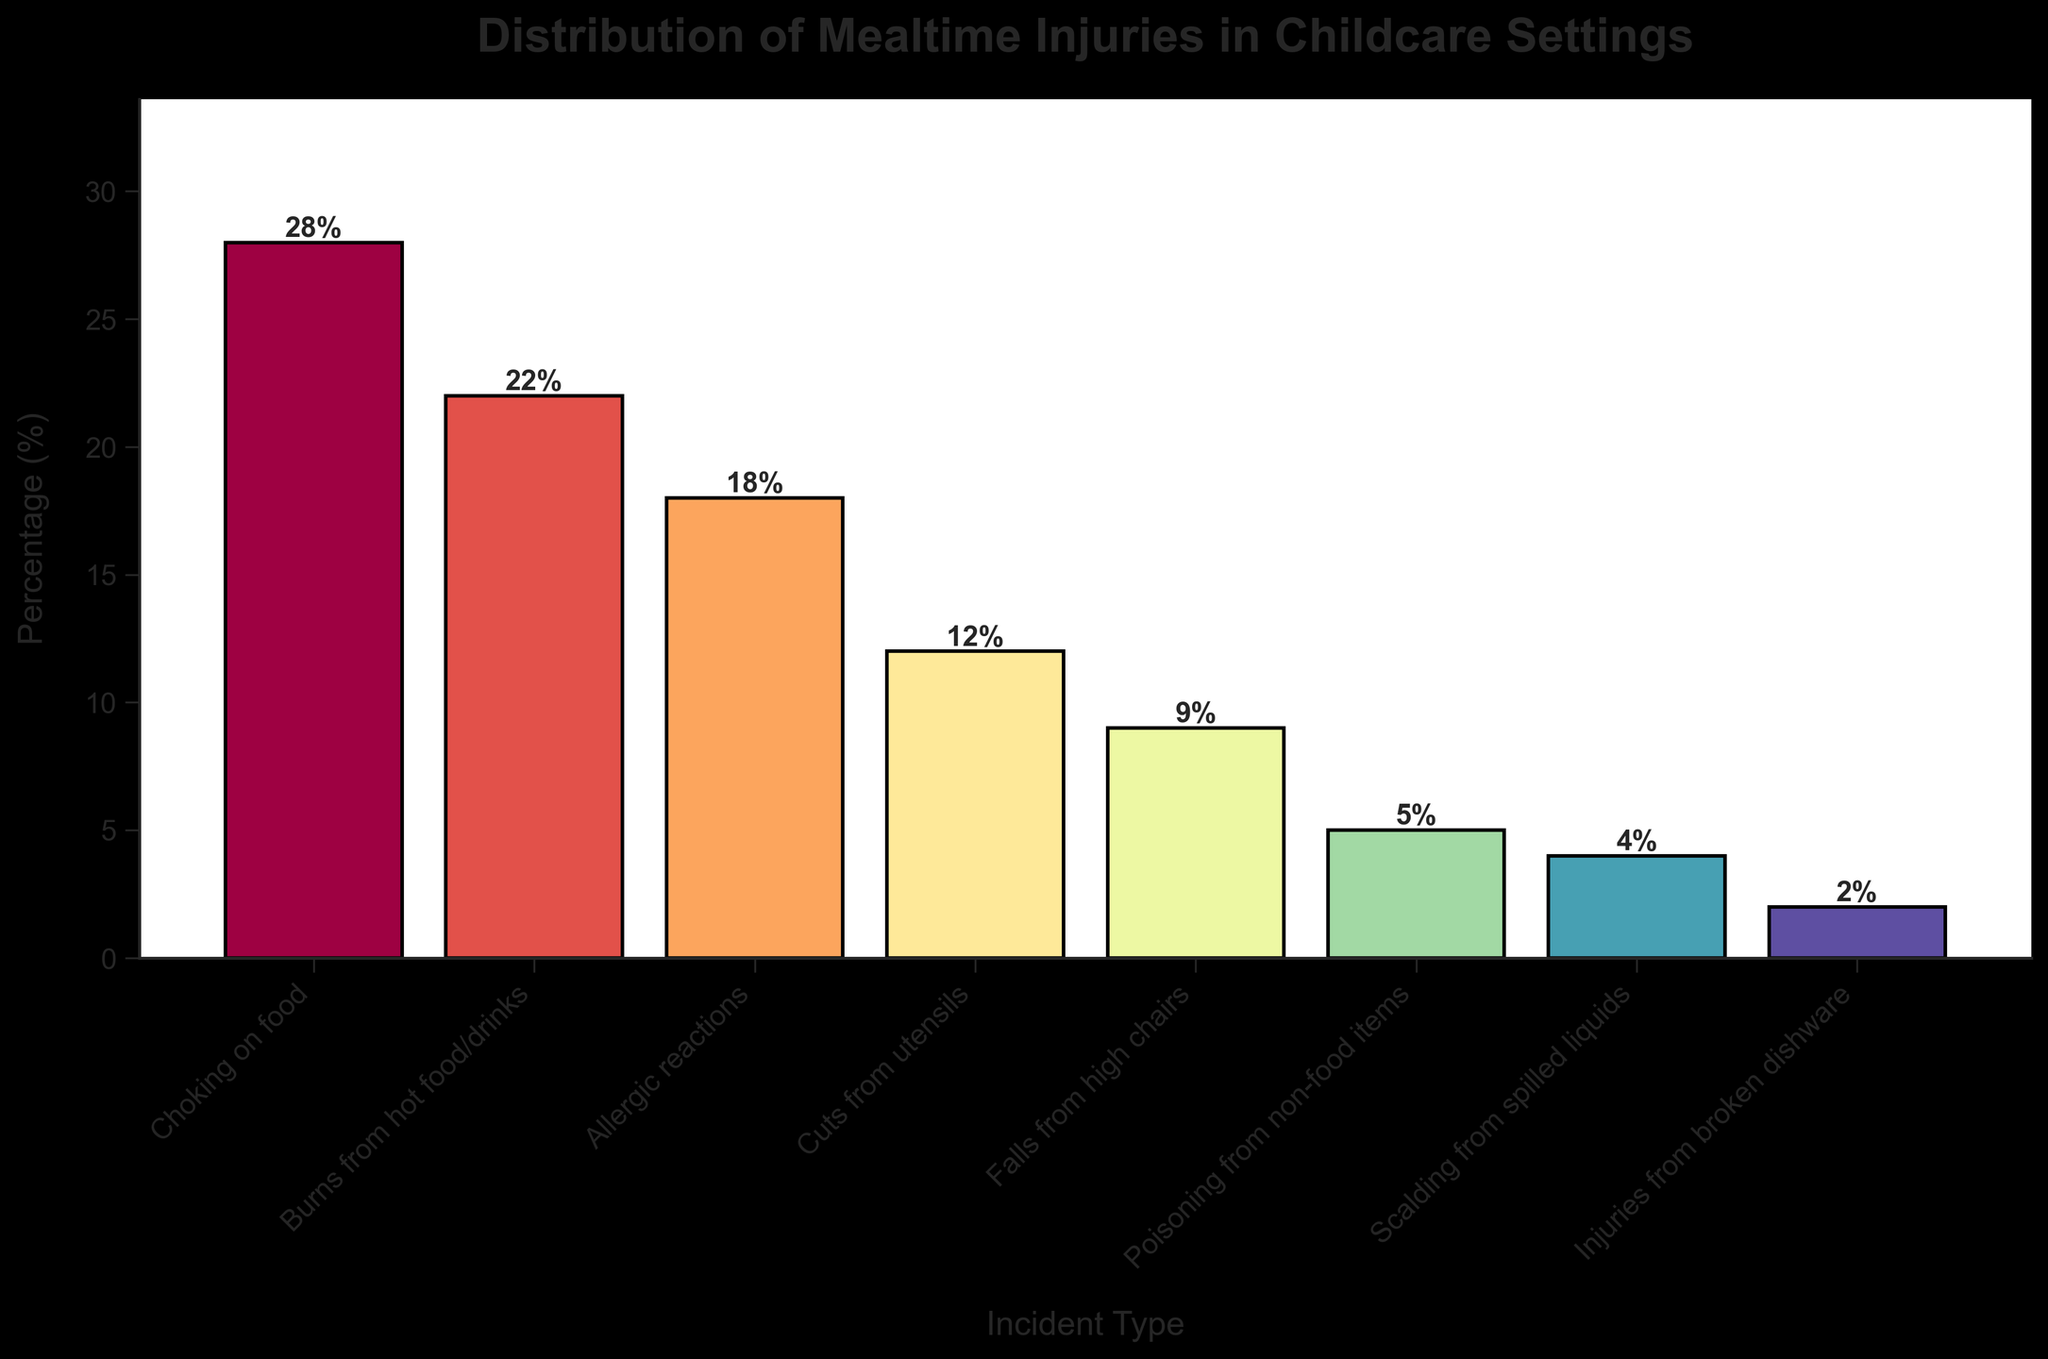What is the most common type of mealtime injury? From the bar chart, the bar representing "Choking on food" is the highest, indicating it has the highest percentage. Therefore, choking on food is the most common type of mealtime injury.
Answer: "Choking on food" Which incident type has the lowest occurrence? The bar chart shows that the bar for "Injuries from broken dishware" is the shortest, indicating this incident type has the lowest occurrence.
Answer: "Injuries from broken dishware" How does the percentage of "Burns from hot food/drinks" compare to "Choking on food"? The bar for "Burns from hot food/drinks" is shorter than the bar for "Choking on food." Specifically, "Burns from hot food/drinks" is 22% and "Choking on food" is 28%, indicating that burns from hot food/drinks are less common.
Answer: "Less common" What is the total percentage of injuries caused by "Burns from hot food/drinks" and "Choking on food"? From the bar chart, the percentage for "Burns from hot food/drinks" is 22%, and "Choking on food" is 28%. Adding these together: 22% + 28% = 50%.
Answer: 50% What is the difference in percentage between "Allergic reactions" and "Cuts from utensils"? According to the bar chart, the percentage for "Allergic reactions" is 18%, and for "Cuts from utensils," it is 12%. The difference is 18% - 12% = 6%.
Answer: 6% What percentage of injuries are caused by "Falls from high chairs" and "Poisoning from non-food items" combined? The bar chart shows that "Falls from high chairs" is 9%, and "Poisoning from non-food items" is 5%. Adding these together: 9% + 5% = 14%.
Answer: 14% Which has a greater percentage: "Scalding from spilled liquids" or "Injuries from broken dishware"? From the bar chart, "Scalding from spilled liquids" has 4%, and "Injuries from broken dishware" has 2%. Thus, "Scalding from spilled liquids" has a greater percentage.
Answer: "Scalding from spilled liquids" What is the average percentage of injuries from "Falls from high chairs," "Poisoning from non-food items," and "Scalding from spilled liquids"? The percentages for these incidents are 9% for "Falls from high chairs," 5% for "Poisoning from non-food items," and 4% for "Scalding from spilled liquids." Adding these gives 9% + 5% + 4% = 18%, and dividing by 3 gives the average: 18% / 3 = 6%.
Answer: 6% If you combined the percentages for "Burns from hot food/drinks" and "Allergic reactions," would it be greater than the percentage for "Choking on food"? "Burns from hot food/drinks" is 22%, and "Allergic reactions" is 18%; combined, they are 22% + 18% = 40%. Since "Choking on food" is 28%, 40% is indeed greater.
Answer: "Yes" 